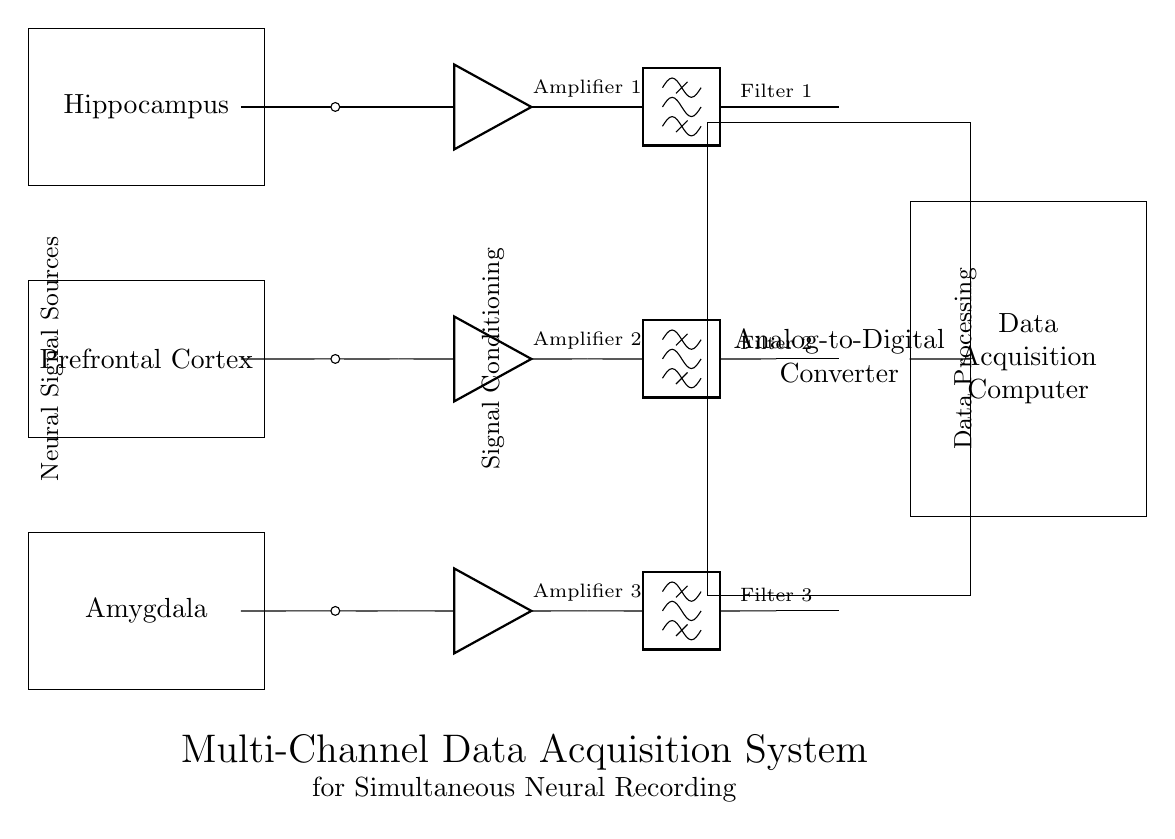What are the brain regions represented in the circuit diagram? The circuit diagram shows three brain regions: Hippocampus, Prefrontal Cortex, and Amygdala, which are explicitly labeled in separate rectangles.
Answer: Hippocampus, Prefrontal Cortex, Amygdala How many amplifiers are used in this system? The diagram depicts three amplifiers, each corresponding to one of the brain regions, labeled as Amplifier 1, Amplifier 2, and Amplifier 3.
Answer: Three What is the function of the bandpass filters in the circuit? The bandpass filters are intended to isolate specific frequency ranges of the neural signals obtained from the amplifiers, enhancing the quality of the recorded signals by removing unwanted noise.
Answer: Noise reduction Which component converts the analog signals to digital format? The component that performs analog-to-digital conversion, as indicated in the diagram, is the Analog-to-Digital Converter labeled ADC.
Answer: Analog-to-Digital Converter What is the overall purpose of the multi-channel data acquisition system? The system is designed to simultaneously record neural signals from different brain regions, facilitating the analysis of these signals in studying neural activity related to memory formation and consolidation.
Answer: Simultaneous neural recording Which region connects to Amplifier 2? The Prefrontal Cortex connects to Amplifier 2, as shown by the direct line linking the second brain region node to the amplifier symbol.
Answer: Prefrontal Cortex 